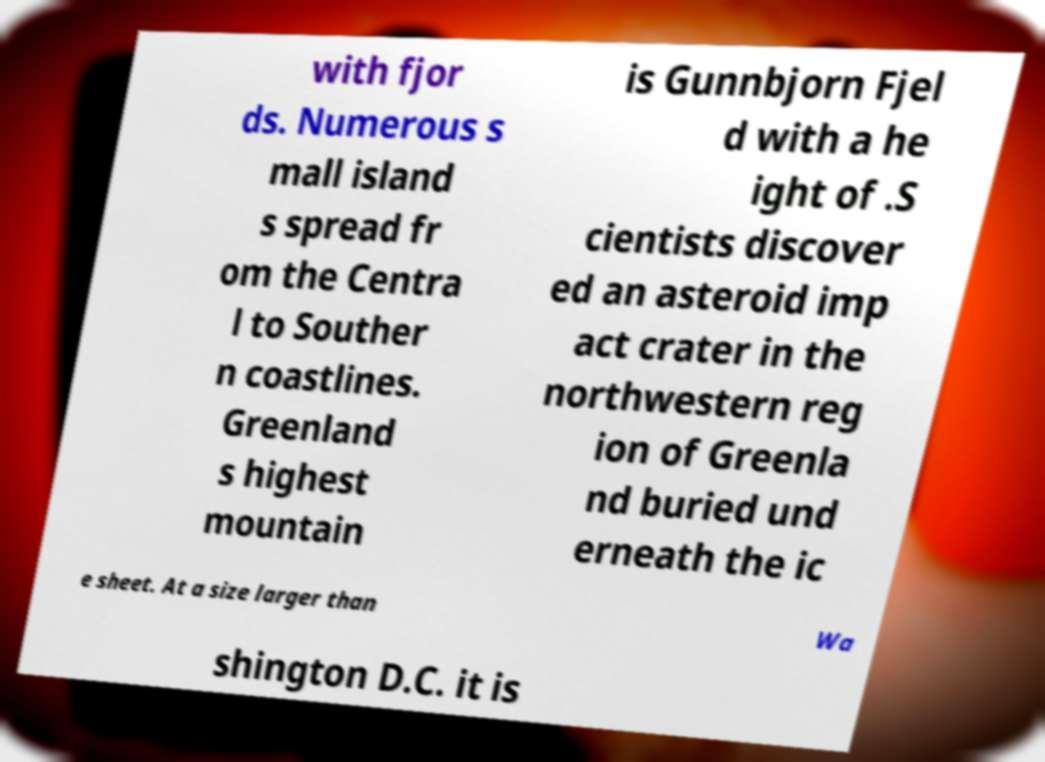I need the written content from this picture converted into text. Can you do that? with fjor ds. Numerous s mall island s spread fr om the Centra l to Souther n coastlines. Greenland s highest mountain is Gunnbjorn Fjel d with a he ight of .S cientists discover ed an asteroid imp act crater in the northwestern reg ion of Greenla nd buried und erneath the ic e sheet. At a size larger than Wa shington D.C. it is 